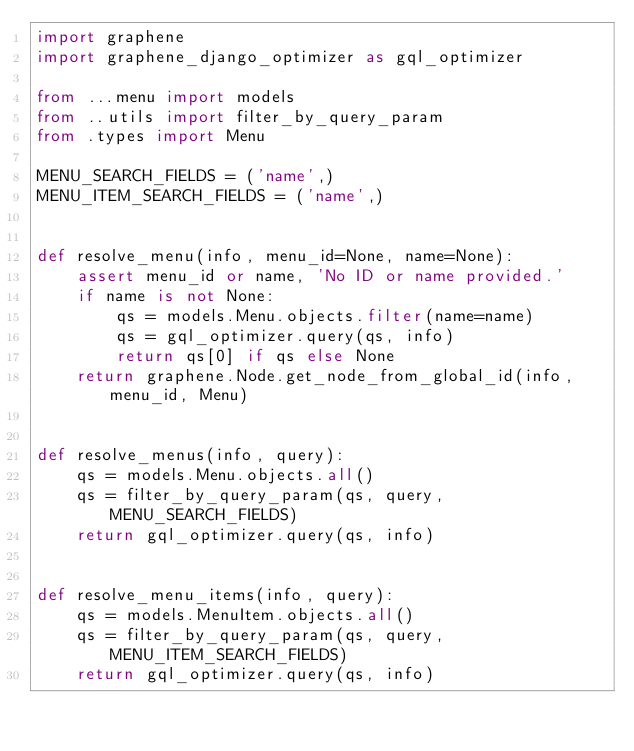Convert code to text. <code><loc_0><loc_0><loc_500><loc_500><_Python_>import graphene
import graphene_django_optimizer as gql_optimizer

from ...menu import models
from ..utils import filter_by_query_param
from .types import Menu

MENU_SEARCH_FIELDS = ('name',)
MENU_ITEM_SEARCH_FIELDS = ('name',)


def resolve_menu(info, menu_id=None, name=None):
    assert menu_id or name, 'No ID or name provided.'
    if name is not None:
        qs = models.Menu.objects.filter(name=name)
        qs = gql_optimizer.query(qs, info)
        return qs[0] if qs else None
    return graphene.Node.get_node_from_global_id(info, menu_id, Menu)


def resolve_menus(info, query):
    qs = models.Menu.objects.all()
    qs = filter_by_query_param(qs, query, MENU_SEARCH_FIELDS)
    return gql_optimizer.query(qs, info)


def resolve_menu_items(info, query):
    qs = models.MenuItem.objects.all()
    qs = filter_by_query_param(qs, query, MENU_ITEM_SEARCH_FIELDS)
    return gql_optimizer.query(qs, info)
</code> 